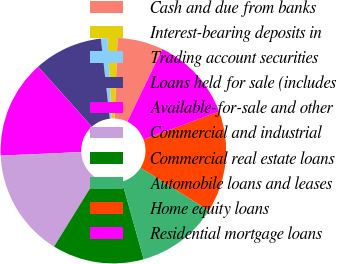Convert chart. <chart><loc_0><loc_0><loc_500><loc_500><pie_chart><fcel>Cash and due from banks<fcel>Interest-bearing deposits in<fcel>Trading account securities<fcel>Loans held for sale (includes<fcel>Available-for-sale and other<fcel>Commercial and industrial<fcel>Commercial real estate loans<fcel>Automobile loans and leases<fcel>Home equity loans<fcel>Residential mortgage loans<nl><fcel>6.57%<fcel>1.41%<fcel>0.94%<fcel>9.86%<fcel>14.08%<fcel>15.49%<fcel>13.15%<fcel>11.74%<fcel>14.55%<fcel>12.21%<nl></chart> 